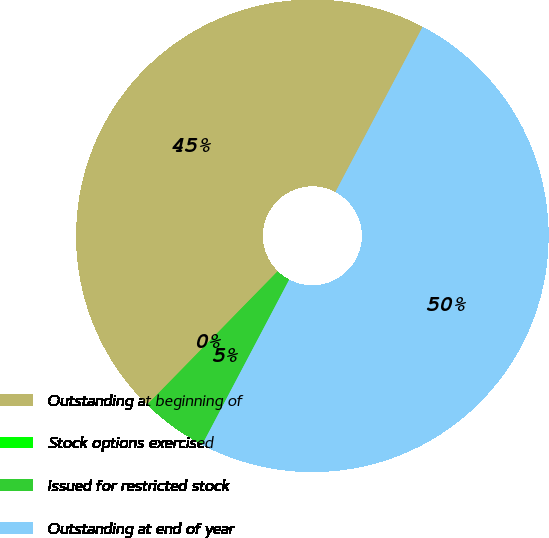<chart> <loc_0><loc_0><loc_500><loc_500><pie_chart><fcel>Outstanding at beginning of<fcel>Stock options exercised<fcel>Issued for restricted stock<fcel>Outstanding at end of year<nl><fcel>45.41%<fcel>0.01%<fcel>4.59%<fcel>49.99%<nl></chart> 